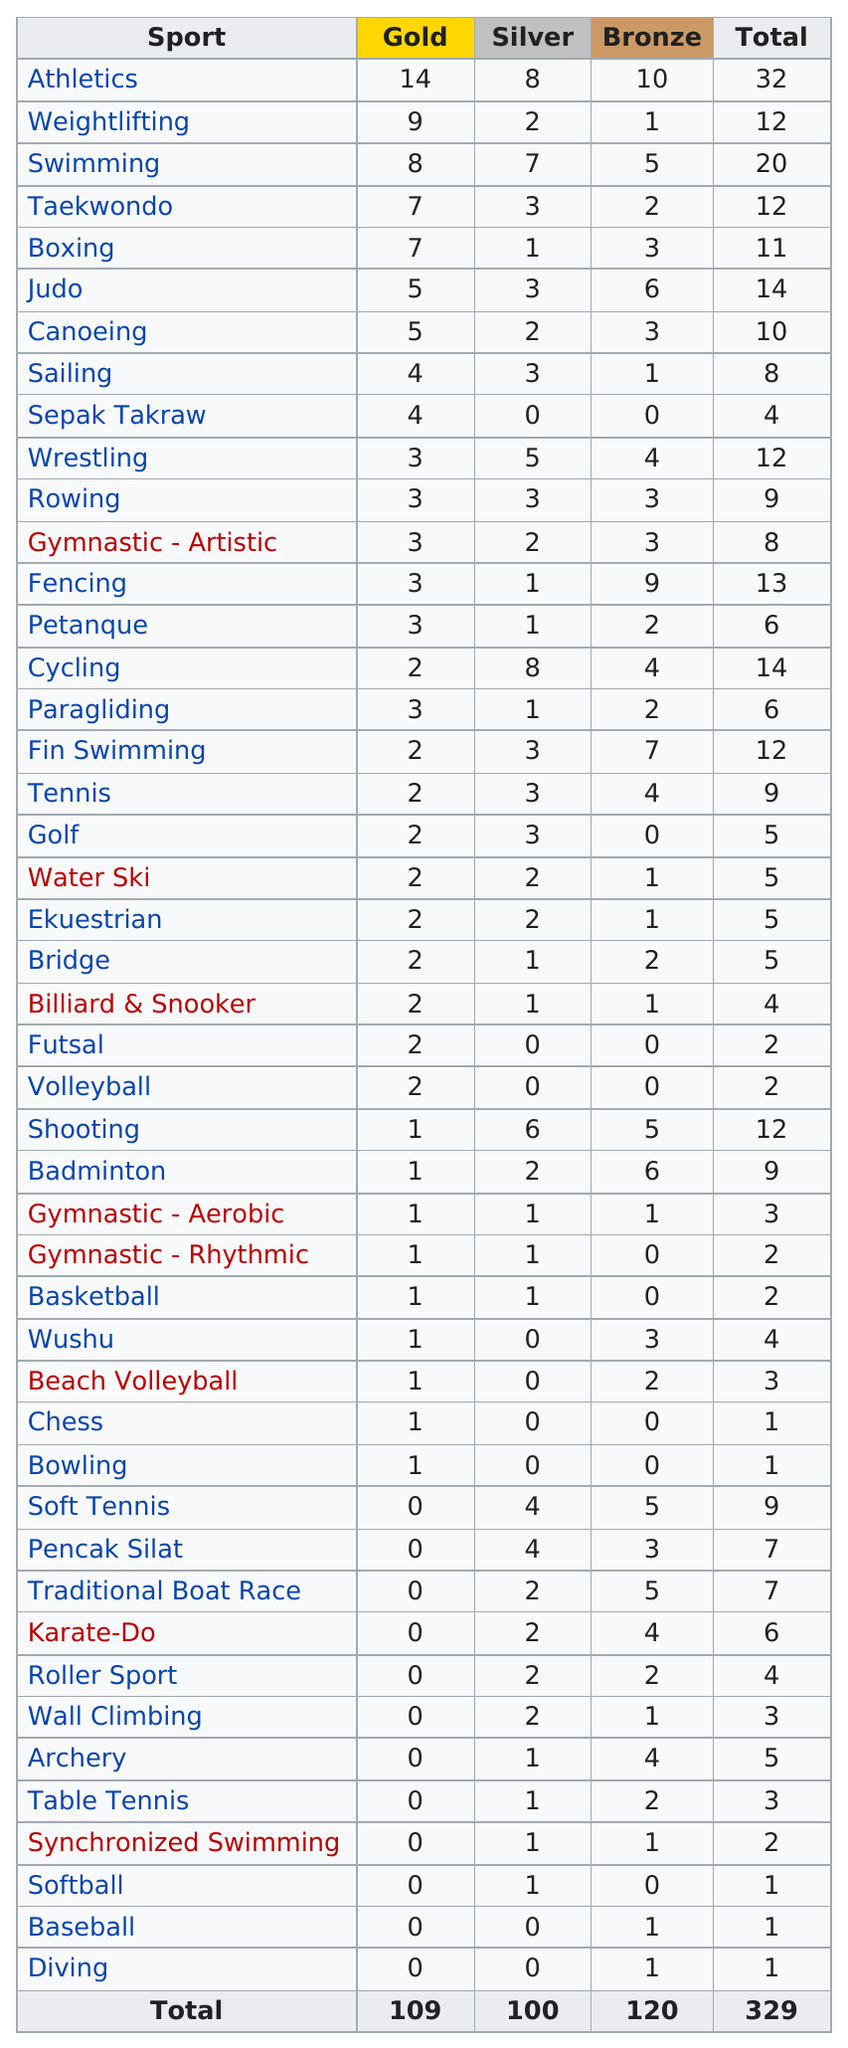Give some essential details in this illustration. In the rowing category, the number of gold medals won in a row is three. Weightlifting is the sport that has won the second highest number of gold medals. The number of silver medals that boxing has is 1. The sport that is listed next after canoeing is sailing. Weightlifting is the only sport that has won a record-breaking nine gold medals. 